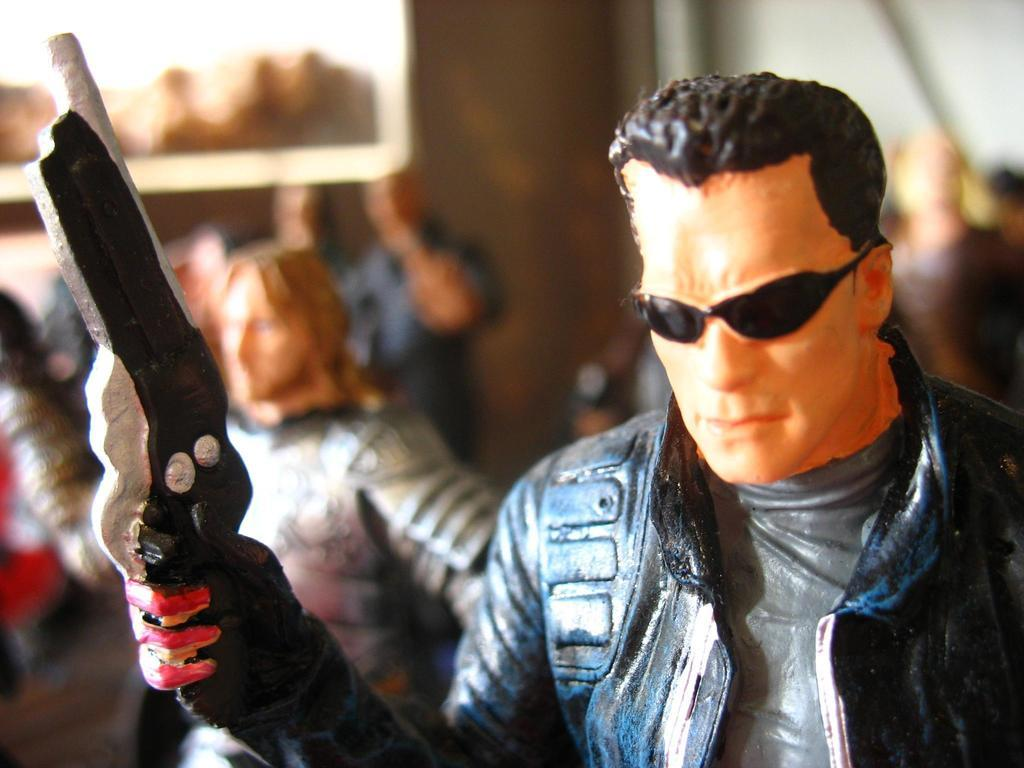What is the main subject of the image? There is a person in the image. Can you describe the background of the image? The background of the image is blurred. What type of income does the owner of the verse in the image earn? There is no mention of an owner or a verse in the image, so it is not possible to determine the income of the owner. 